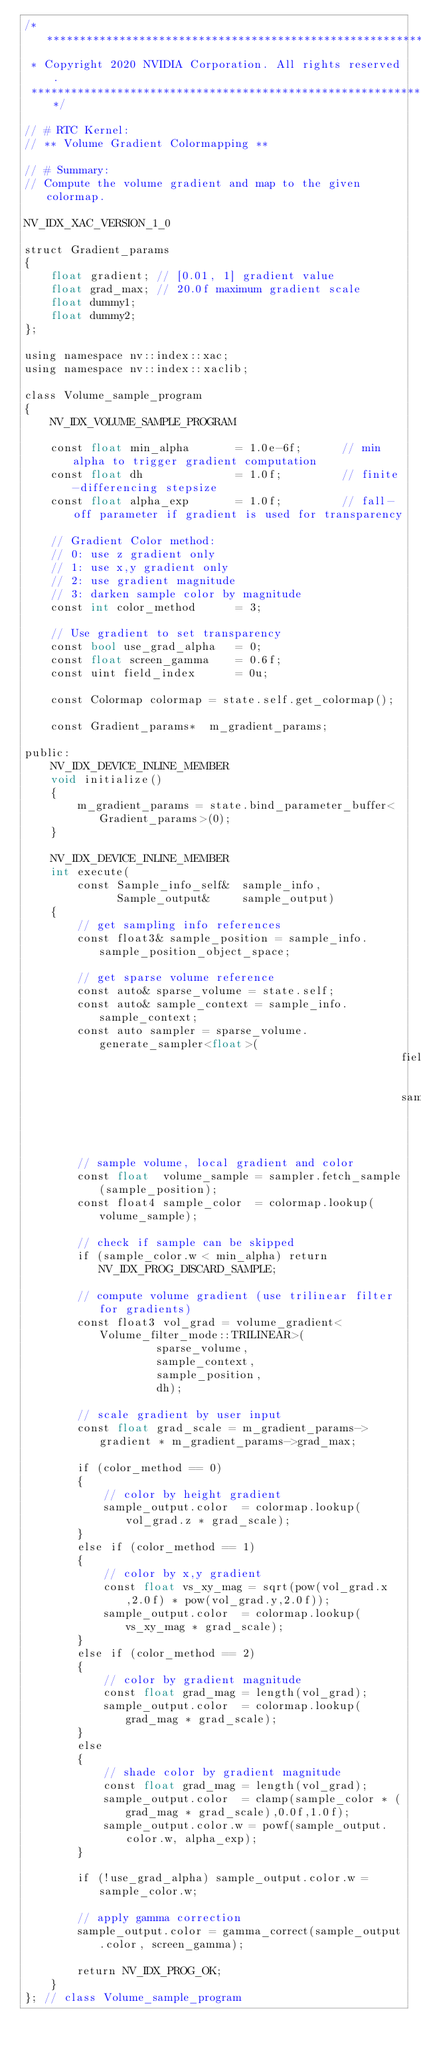<code> <loc_0><loc_0><loc_500><loc_500><_Cuda_>/******************************************************************************
 * Copyright 2020 NVIDIA Corporation. All rights reserved.
 *****************************************************************************/

// # RTC Kernel:
// ** Volume Gradient Colormapping **

// # Summary:
// Compute the volume gradient and map to the given colormap.

NV_IDX_XAC_VERSION_1_0

struct Gradient_params
{
    float gradient; // [0.01, 1] gradient value
    float grad_max; // 20.0f maximum gradient scale
    float dummy1;
    float dummy2;
};

using namespace nv::index::xac;
using namespace nv::index::xaclib;

class Volume_sample_program
{
    NV_IDX_VOLUME_SAMPLE_PROGRAM

    const float min_alpha       = 1.0e-6f;      // min alpha to trigger gradient computation
    const float dh              = 1.0f;         // finite-differencing stepsize
    const float alpha_exp       = 1.0f;         // fall-off parameter if gradient is used for transparency

    // Gradient Color method:
    // 0: use z gradient only
    // 1: use x,y gradient only
    // 2: use gradient magnitude
    // 3: darken sample color by magnitude
    const int color_method      = 3;

    // Use gradient to set transparency
    const bool use_grad_alpha   = 0;
    const float screen_gamma    = 0.6f;
    const uint field_index      = 0u;

    const Colormap colormap = state.self.get_colormap();

    const Gradient_params*  m_gradient_params;

public:
    NV_IDX_DEVICE_INLINE_MEMBER
    void initialize()
    {
        m_gradient_params = state.bind_parameter_buffer<Gradient_params>(0);
    }

    NV_IDX_DEVICE_INLINE_MEMBER
    int execute(
        const Sample_info_self&  sample_info,
              Sample_output&     sample_output)
    {
        // get sampling info references
        const float3& sample_position = sample_info.sample_position_object_space;

        // get sparse volume reference
        const auto& sparse_volume = state.self;
        const auto& sample_context = sample_info.sample_context;
        const auto sampler = sparse_volume.generate_sampler<float>(
                                                         field_index,
                                                         sample_context);

        // sample volume, local gradient and color
        const float  volume_sample = sampler.fetch_sample(sample_position);
        const float4 sample_color  = colormap.lookup(volume_sample);

        // check if sample can be skipped
        if (sample_color.w < min_alpha) return NV_IDX_PROG_DISCARD_SAMPLE;

        // compute volume gradient (use trilinear filter for gradients)
        const float3 vol_grad = volume_gradient<Volume_filter_mode::TRILINEAR>(
                    sparse_volume,
                    sample_context,
                    sample_position,
                    dh);

        // scale gradient by user input
        const float grad_scale = m_gradient_params->gradient * m_gradient_params->grad_max;

        if (color_method == 0)
        {
            // color by height gradient
            sample_output.color  = colormap.lookup(vol_grad.z * grad_scale);
        }
        else if (color_method == 1)
        {
            // color by x,y gradient
            const float vs_xy_mag = sqrt(pow(vol_grad.x,2.0f) * pow(vol_grad.y,2.0f));
            sample_output.color  = colormap.lookup(vs_xy_mag * grad_scale);
        }
        else if (color_method == 2)
        {
            // color by gradient magnitude
            const float grad_mag = length(vol_grad);
            sample_output.color  = colormap.lookup(grad_mag * grad_scale);
        }
        else
        {
            // shade color by gradient magnitude
            const float grad_mag = length(vol_grad);
            sample_output.color  = clamp(sample_color * (grad_mag * grad_scale),0.0f,1.0f);
            sample_output.color.w = powf(sample_output.color.w, alpha_exp);
        }

        if (!use_grad_alpha) sample_output.color.w = sample_color.w;

        // apply gamma correction
        sample_output.color = gamma_correct(sample_output.color, screen_gamma);

        return NV_IDX_PROG_OK;
    }
}; // class Volume_sample_program
</code> 